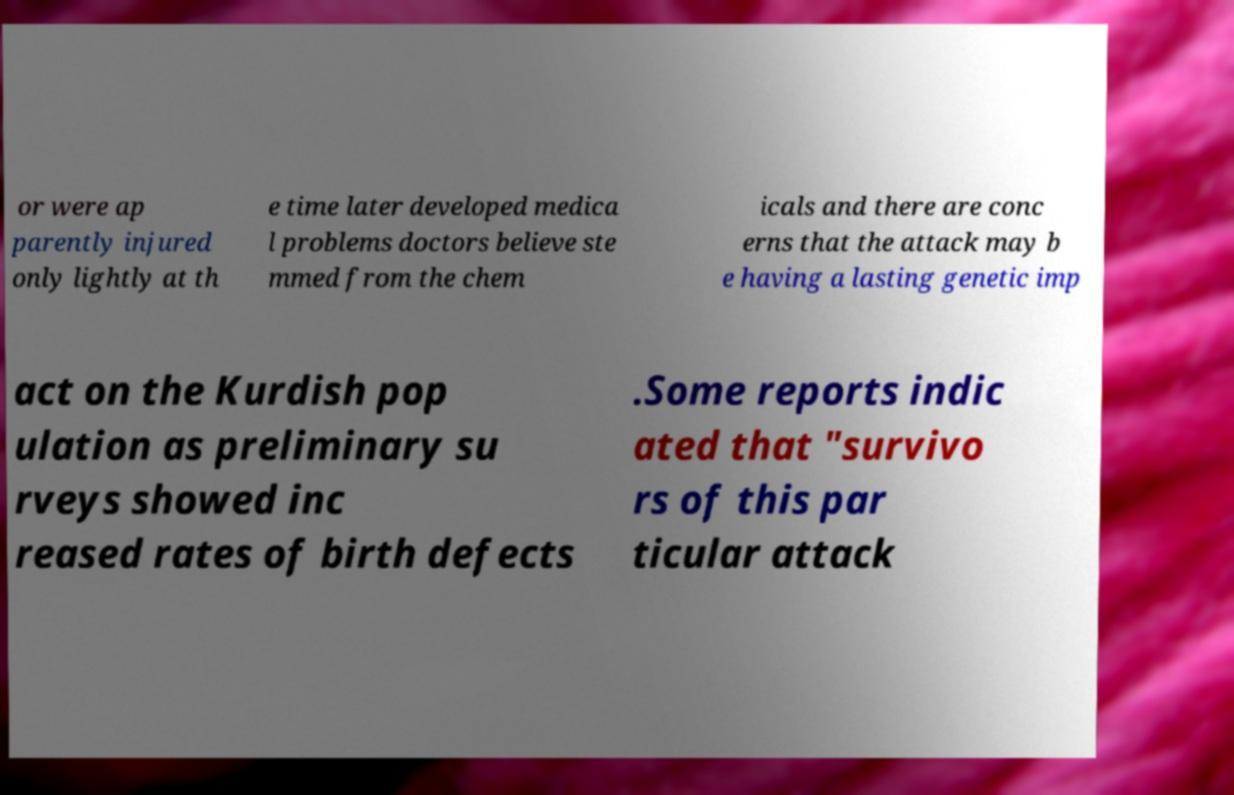Could you extract and type out the text from this image? or were ap parently injured only lightly at th e time later developed medica l problems doctors believe ste mmed from the chem icals and there are conc erns that the attack may b e having a lasting genetic imp act on the Kurdish pop ulation as preliminary su rveys showed inc reased rates of birth defects .Some reports indic ated that "survivo rs of this par ticular attack 